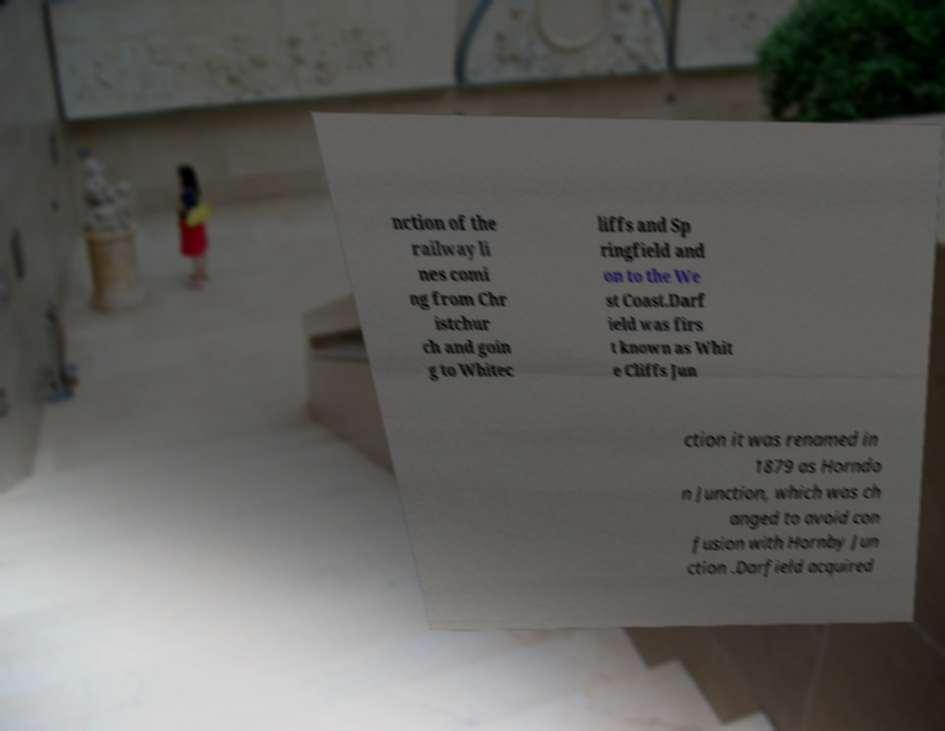Please read and relay the text visible in this image. What does it say? nction of the railway li nes comi ng from Chr istchur ch and goin g to Whitec liffs and Sp ringfield and on to the We st Coast.Darf ield was firs t known as Whit e Cliffs Jun ction it was renamed in 1879 as Horndo n Junction, which was ch anged to avoid con fusion with Hornby Jun ction .Darfield acquired 